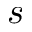<formula> <loc_0><loc_0><loc_500><loc_500>s</formula> 